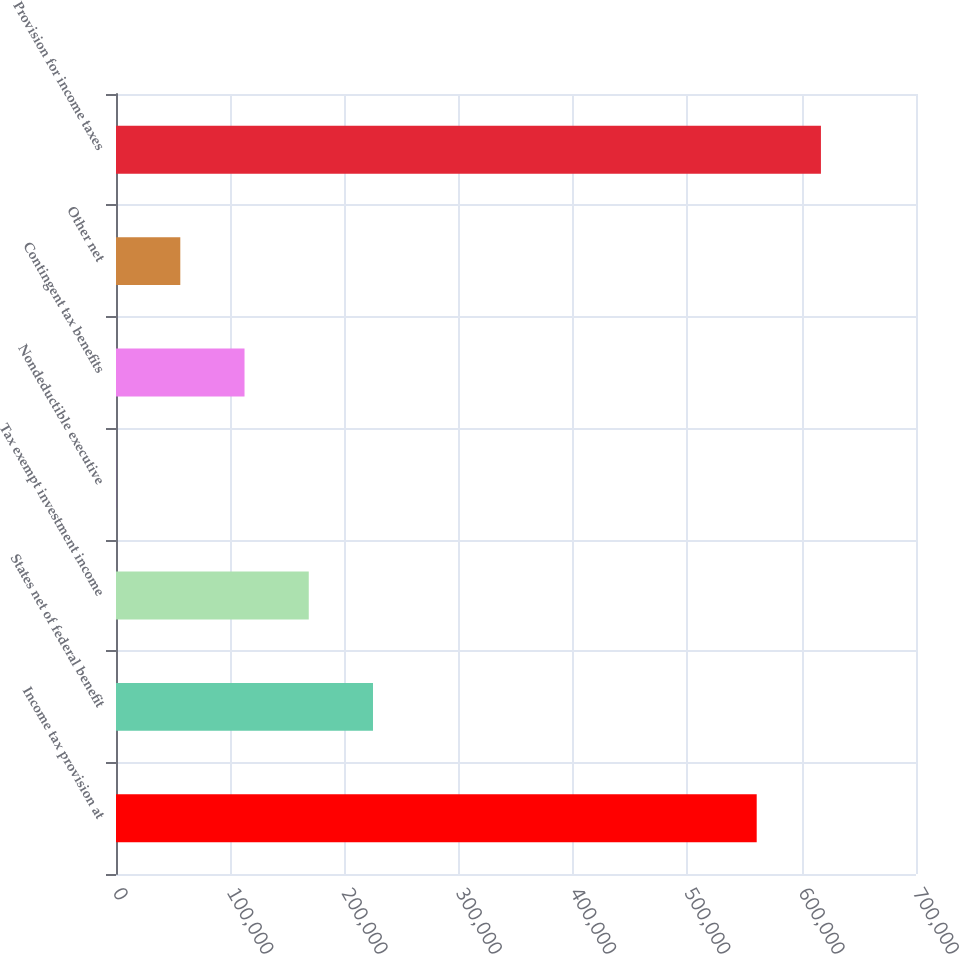Convert chart. <chart><loc_0><loc_0><loc_500><loc_500><bar_chart><fcel>Income tax provision at<fcel>States net of federal benefit<fcel>Tax exempt investment income<fcel>Nondeductible executive<fcel>Contingent tax benefits<fcel>Other net<fcel>Provision for income taxes<nl><fcel>560616<fcel>224867<fcel>168664<fcel>55<fcel>112461<fcel>56258<fcel>616819<nl></chart> 